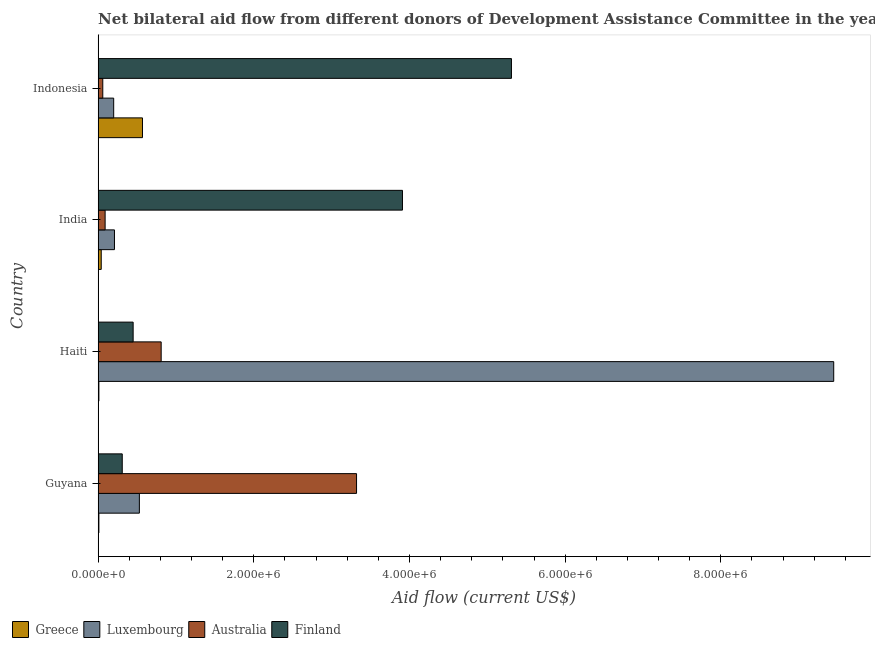How many groups of bars are there?
Make the answer very short. 4. How many bars are there on the 1st tick from the top?
Give a very brief answer. 4. How many bars are there on the 3rd tick from the bottom?
Offer a terse response. 4. What is the label of the 4th group of bars from the top?
Provide a short and direct response. Guyana. What is the amount of aid given by finland in Haiti?
Ensure brevity in your answer.  4.50e+05. Across all countries, what is the maximum amount of aid given by australia?
Make the answer very short. 3.32e+06. Across all countries, what is the minimum amount of aid given by luxembourg?
Make the answer very short. 2.00e+05. In which country was the amount of aid given by australia minimum?
Your answer should be compact. Indonesia. What is the total amount of aid given by finland in the graph?
Provide a succinct answer. 9.98e+06. What is the difference between the amount of aid given by luxembourg in Haiti and that in India?
Your answer should be compact. 9.24e+06. What is the difference between the amount of aid given by australia in Guyana and the amount of aid given by luxembourg in Haiti?
Keep it short and to the point. -6.13e+06. What is the average amount of aid given by australia per country?
Give a very brief answer. 1.07e+06. What is the difference between the amount of aid given by finland and amount of aid given by greece in Haiti?
Your response must be concise. 4.40e+05. In how many countries, is the amount of aid given by finland greater than 5200000 US$?
Ensure brevity in your answer.  1. What is the ratio of the amount of aid given by australia in India to that in Indonesia?
Give a very brief answer. 1.5. What is the difference between the highest and the second highest amount of aid given by finland?
Your response must be concise. 1.40e+06. What is the difference between the highest and the lowest amount of aid given by australia?
Provide a succinct answer. 3.26e+06. What does the 2nd bar from the bottom in India represents?
Make the answer very short. Luxembourg. How many countries are there in the graph?
Ensure brevity in your answer.  4. Does the graph contain any zero values?
Provide a short and direct response. No. Where does the legend appear in the graph?
Your answer should be very brief. Bottom left. What is the title of the graph?
Offer a terse response. Net bilateral aid flow from different donors of Development Assistance Committee in the year 2006. What is the Aid flow (current US$) in Luxembourg in Guyana?
Provide a succinct answer. 5.30e+05. What is the Aid flow (current US$) in Australia in Guyana?
Ensure brevity in your answer.  3.32e+06. What is the Aid flow (current US$) in Finland in Guyana?
Give a very brief answer. 3.10e+05. What is the Aid flow (current US$) of Luxembourg in Haiti?
Offer a terse response. 9.45e+06. What is the Aid flow (current US$) in Australia in Haiti?
Ensure brevity in your answer.  8.10e+05. What is the Aid flow (current US$) in Greece in India?
Make the answer very short. 4.00e+04. What is the Aid flow (current US$) of Luxembourg in India?
Provide a short and direct response. 2.10e+05. What is the Aid flow (current US$) in Australia in India?
Your response must be concise. 9.00e+04. What is the Aid flow (current US$) of Finland in India?
Provide a succinct answer. 3.91e+06. What is the Aid flow (current US$) in Greece in Indonesia?
Ensure brevity in your answer.  5.70e+05. What is the Aid flow (current US$) of Australia in Indonesia?
Your answer should be very brief. 6.00e+04. What is the Aid flow (current US$) of Finland in Indonesia?
Keep it short and to the point. 5.31e+06. Across all countries, what is the maximum Aid flow (current US$) of Greece?
Offer a terse response. 5.70e+05. Across all countries, what is the maximum Aid flow (current US$) in Luxembourg?
Provide a short and direct response. 9.45e+06. Across all countries, what is the maximum Aid flow (current US$) in Australia?
Provide a succinct answer. 3.32e+06. Across all countries, what is the maximum Aid flow (current US$) of Finland?
Provide a succinct answer. 5.31e+06. Across all countries, what is the minimum Aid flow (current US$) of Luxembourg?
Provide a succinct answer. 2.00e+05. Across all countries, what is the minimum Aid flow (current US$) in Finland?
Your answer should be compact. 3.10e+05. What is the total Aid flow (current US$) in Greece in the graph?
Your answer should be very brief. 6.30e+05. What is the total Aid flow (current US$) in Luxembourg in the graph?
Your answer should be compact. 1.04e+07. What is the total Aid flow (current US$) in Australia in the graph?
Offer a terse response. 4.28e+06. What is the total Aid flow (current US$) of Finland in the graph?
Offer a very short reply. 9.98e+06. What is the difference between the Aid flow (current US$) of Greece in Guyana and that in Haiti?
Give a very brief answer. 0. What is the difference between the Aid flow (current US$) in Luxembourg in Guyana and that in Haiti?
Offer a very short reply. -8.92e+06. What is the difference between the Aid flow (current US$) in Australia in Guyana and that in Haiti?
Your answer should be compact. 2.51e+06. What is the difference between the Aid flow (current US$) in Finland in Guyana and that in Haiti?
Your answer should be compact. -1.40e+05. What is the difference between the Aid flow (current US$) of Australia in Guyana and that in India?
Your response must be concise. 3.23e+06. What is the difference between the Aid flow (current US$) in Finland in Guyana and that in India?
Ensure brevity in your answer.  -3.60e+06. What is the difference between the Aid flow (current US$) in Greece in Guyana and that in Indonesia?
Offer a terse response. -5.60e+05. What is the difference between the Aid flow (current US$) of Australia in Guyana and that in Indonesia?
Offer a very short reply. 3.26e+06. What is the difference between the Aid flow (current US$) of Finland in Guyana and that in Indonesia?
Make the answer very short. -5.00e+06. What is the difference between the Aid flow (current US$) of Luxembourg in Haiti and that in India?
Your response must be concise. 9.24e+06. What is the difference between the Aid flow (current US$) of Australia in Haiti and that in India?
Provide a succinct answer. 7.20e+05. What is the difference between the Aid flow (current US$) of Finland in Haiti and that in India?
Your answer should be very brief. -3.46e+06. What is the difference between the Aid flow (current US$) of Greece in Haiti and that in Indonesia?
Offer a very short reply. -5.60e+05. What is the difference between the Aid flow (current US$) of Luxembourg in Haiti and that in Indonesia?
Make the answer very short. 9.25e+06. What is the difference between the Aid flow (current US$) in Australia in Haiti and that in Indonesia?
Offer a very short reply. 7.50e+05. What is the difference between the Aid flow (current US$) of Finland in Haiti and that in Indonesia?
Ensure brevity in your answer.  -4.86e+06. What is the difference between the Aid flow (current US$) in Greece in India and that in Indonesia?
Offer a terse response. -5.30e+05. What is the difference between the Aid flow (current US$) of Finland in India and that in Indonesia?
Make the answer very short. -1.40e+06. What is the difference between the Aid flow (current US$) of Greece in Guyana and the Aid flow (current US$) of Luxembourg in Haiti?
Your answer should be compact. -9.44e+06. What is the difference between the Aid flow (current US$) of Greece in Guyana and the Aid flow (current US$) of Australia in Haiti?
Keep it short and to the point. -8.00e+05. What is the difference between the Aid flow (current US$) of Greece in Guyana and the Aid flow (current US$) of Finland in Haiti?
Provide a short and direct response. -4.40e+05. What is the difference between the Aid flow (current US$) in Luxembourg in Guyana and the Aid flow (current US$) in Australia in Haiti?
Provide a succinct answer. -2.80e+05. What is the difference between the Aid flow (current US$) in Australia in Guyana and the Aid flow (current US$) in Finland in Haiti?
Your answer should be compact. 2.87e+06. What is the difference between the Aid flow (current US$) in Greece in Guyana and the Aid flow (current US$) in Luxembourg in India?
Provide a succinct answer. -2.00e+05. What is the difference between the Aid flow (current US$) in Greece in Guyana and the Aid flow (current US$) in Finland in India?
Provide a short and direct response. -3.90e+06. What is the difference between the Aid flow (current US$) of Luxembourg in Guyana and the Aid flow (current US$) of Australia in India?
Offer a terse response. 4.40e+05. What is the difference between the Aid flow (current US$) in Luxembourg in Guyana and the Aid flow (current US$) in Finland in India?
Your response must be concise. -3.38e+06. What is the difference between the Aid flow (current US$) in Australia in Guyana and the Aid flow (current US$) in Finland in India?
Provide a short and direct response. -5.90e+05. What is the difference between the Aid flow (current US$) in Greece in Guyana and the Aid flow (current US$) in Australia in Indonesia?
Your answer should be compact. -5.00e+04. What is the difference between the Aid flow (current US$) of Greece in Guyana and the Aid flow (current US$) of Finland in Indonesia?
Offer a very short reply. -5.30e+06. What is the difference between the Aid flow (current US$) of Luxembourg in Guyana and the Aid flow (current US$) of Australia in Indonesia?
Your answer should be compact. 4.70e+05. What is the difference between the Aid flow (current US$) of Luxembourg in Guyana and the Aid flow (current US$) of Finland in Indonesia?
Keep it short and to the point. -4.78e+06. What is the difference between the Aid flow (current US$) in Australia in Guyana and the Aid flow (current US$) in Finland in Indonesia?
Offer a terse response. -1.99e+06. What is the difference between the Aid flow (current US$) in Greece in Haiti and the Aid flow (current US$) in Finland in India?
Keep it short and to the point. -3.90e+06. What is the difference between the Aid flow (current US$) of Luxembourg in Haiti and the Aid flow (current US$) of Australia in India?
Your answer should be very brief. 9.36e+06. What is the difference between the Aid flow (current US$) in Luxembourg in Haiti and the Aid flow (current US$) in Finland in India?
Offer a very short reply. 5.54e+06. What is the difference between the Aid flow (current US$) of Australia in Haiti and the Aid flow (current US$) of Finland in India?
Offer a terse response. -3.10e+06. What is the difference between the Aid flow (current US$) in Greece in Haiti and the Aid flow (current US$) in Finland in Indonesia?
Offer a very short reply. -5.30e+06. What is the difference between the Aid flow (current US$) of Luxembourg in Haiti and the Aid flow (current US$) of Australia in Indonesia?
Offer a very short reply. 9.39e+06. What is the difference between the Aid flow (current US$) in Luxembourg in Haiti and the Aid flow (current US$) in Finland in Indonesia?
Make the answer very short. 4.14e+06. What is the difference between the Aid flow (current US$) of Australia in Haiti and the Aid flow (current US$) of Finland in Indonesia?
Offer a terse response. -4.50e+06. What is the difference between the Aid flow (current US$) of Greece in India and the Aid flow (current US$) of Luxembourg in Indonesia?
Offer a terse response. -1.60e+05. What is the difference between the Aid flow (current US$) in Greece in India and the Aid flow (current US$) in Australia in Indonesia?
Provide a short and direct response. -2.00e+04. What is the difference between the Aid flow (current US$) in Greece in India and the Aid flow (current US$) in Finland in Indonesia?
Give a very brief answer. -5.27e+06. What is the difference between the Aid flow (current US$) in Luxembourg in India and the Aid flow (current US$) in Australia in Indonesia?
Keep it short and to the point. 1.50e+05. What is the difference between the Aid flow (current US$) in Luxembourg in India and the Aid flow (current US$) in Finland in Indonesia?
Your answer should be compact. -5.10e+06. What is the difference between the Aid flow (current US$) of Australia in India and the Aid flow (current US$) of Finland in Indonesia?
Your answer should be compact. -5.22e+06. What is the average Aid flow (current US$) of Greece per country?
Your response must be concise. 1.58e+05. What is the average Aid flow (current US$) of Luxembourg per country?
Your response must be concise. 2.60e+06. What is the average Aid flow (current US$) of Australia per country?
Your answer should be compact. 1.07e+06. What is the average Aid flow (current US$) of Finland per country?
Provide a succinct answer. 2.50e+06. What is the difference between the Aid flow (current US$) of Greece and Aid flow (current US$) of Luxembourg in Guyana?
Offer a very short reply. -5.20e+05. What is the difference between the Aid flow (current US$) in Greece and Aid flow (current US$) in Australia in Guyana?
Your answer should be very brief. -3.31e+06. What is the difference between the Aid flow (current US$) of Greece and Aid flow (current US$) of Finland in Guyana?
Give a very brief answer. -3.00e+05. What is the difference between the Aid flow (current US$) of Luxembourg and Aid flow (current US$) of Australia in Guyana?
Offer a terse response. -2.79e+06. What is the difference between the Aid flow (current US$) in Australia and Aid flow (current US$) in Finland in Guyana?
Provide a succinct answer. 3.01e+06. What is the difference between the Aid flow (current US$) in Greece and Aid flow (current US$) in Luxembourg in Haiti?
Give a very brief answer. -9.44e+06. What is the difference between the Aid flow (current US$) of Greece and Aid flow (current US$) of Australia in Haiti?
Ensure brevity in your answer.  -8.00e+05. What is the difference between the Aid flow (current US$) of Greece and Aid flow (current US$) of Finland in Haiti?
Your response must be concise. -4.40e+05. What is the difference between the Aid flow (current US$) of Luxembourg and Aid flow (current US$) of Australia in Haiti?
Your response must be concise. 8.64e+06. What is the difference between the Aid flow (current US$) in Luxembourg and Aid flow (current US$) in Finland in Haiti?
Give a very brief answer. 9.00e+06. What is the difference between the Aid flow (current US$) in Australia and Aid flow (current US$) in Finland in Haiti?
Your answer should be compact. 3.60e+05. What is the difference between the Aid flow (current US$) of Greece and Aid flow (current US$) of Luxembourg in India?
Give a very brief answer. -1.70e+05. What is the difference between the Aid flow (current US$) in Greece and Aid flow (current US$) in Finland in India?
Offer a terse response. -3.87e+06. What is the difference between the Aid flow (current US$) in Luxembourg and Aid flow (current US$) in Australia in India?
Offer a very short reply. 1.20e+05. What is the difference between the Aid flow (current US$) of Luxembourg and Aid flow (current US$) of Finland in India?
Your answer should be very brief. -3.70e+06. What is the difference between the Aid flow (current US$) in Australia and Aid flow (current US$) in Finland in India?
Your answer should be very brief. -3.82e+06. What is the difference between the Aid flow (current US$) in Greece and Aid flow (current US$) in Luxembourg in Indonesia?
Your answer should be compact. 3.70e+05. What is the difference between the Aid flow (current US$) of Greece and Aid flow (current US$) of Australia in Indonesia?
Your response must be concise. 5.10e+05. What is the difference between the Aid flow (current US$) in Greece and Aid flow (current US$) in Finland in Indonesia?
Offer a terse response. -4.74e+06. What is the difference between the Aid flow (current US$) of Luxembourg and Aid flow (current US$) of Finland in Indonesia?
Provide a short and direct response. -5.11e+06. What is the difference between the Aid flow (current US$) in Australia and Aid flow (current US$) in Finland in Indonesia?
Offer a very short reply. -5.25e+06. What is the ratio of the Aid flow (current US$) in Luxembourg in Guyana to that in Haiti?
Provide a succinct answer. 0.06. What is the ratio of the Aid flow (current US$) of Australia in Guyana to that in Haiti?
Keep it short and to the point. 4.1. What is the ratio of the Aid flow (current US$) in Finland in Guyana to that in Haiti?
Give a very brief answer. 0.69. What is the ratio of the Aid flow (current US$) of Luxembourg in Guyana to that in India?
Provide a succinct answer. 2.52. What is the ratio of the Aid flow (current US$) in Australia in Guyana to that in India?
Provide a short and direct response. 36.89. What is the ratio of the Aid flow (current US$) in Finland in Guyana to that in India?
Provide a succinct answer. 0.08. What is the ratio of the Aid flow (current US$) in Greece in Guyana to that in Indonesia?
Provide a short and direct response. 0.02. What is the ratio of the Aid flow (current US$) of Luxembourg in Guyana to that in Indonesia?
Provide a succinct answer. 2.65. What is the ratio of the Aid flow (current US$) of Australia in Guyana to that in Indonesia?
Your answer should be very brief. 55.33. What is the ratio of the Aid flow (current US$) of Finland in Guyana to that in Indonesia?
Your answer should be compact. 0.06. What is the ratio of the Aid flow (current US$) in Finland in Haiti to that in India?
Offer a very short reply. 0.12. What is the ratio of the Aid flow (current US$) in Greece in Haiti to that in Indonesia?
Provide a succinct answer. 0.02. What is the ratio of the Aid flow (current US$) in Luxembourg in Haiti to that in Indonesia?
Offer a terse response. 47.25. What is the ratio of the Aid flow (current US$) in Finland in Haiti to that in Indonesia?
Provide a short and direct response. 0.08. What is the ratio of the Aid flow (current US$) in Greece in India to that in Indonesia?
Your answer should be compact. 0.07. What is the ratio of the Aid flow (current US$) in Luxembourg in India to that in Indonesia?
Provide a short and direct response. 1.05. What is the ratio of the Aid flow (current US$) in Australia in India to that in Indonesia?
Offer a very short reply. 1.5. What is the ratio of the Aid flow (current US$) in Finland in India to that in Indonesia?
Give a very brief answer. 0.74. What is the difference between the highest and the second highest Aid flow (current US$) in Greece?
Make the answer very short. 5.30e+05. What is the difference between the highest and the second highest Aid flow (current US$) of Luxembourg?
Ensure brevity in your answer.  8.92e+06. What is the difference between the highest and the second highest Aid flow (current US$) in Australia?
Your answer should be compact. 2.51e+06. What is the difference between the highest and the second highest Aid flow (current US$) of Finland?
Give a very brief answer. 1.40e+06. What is the difference between the highest and the lowest Aid flow (current US$) in Greece?
Give a very brief answer. 5.60e+05. What is the difference between the highest and the lowest Aid flow (current US$) in Luxembourg?
Provide a short and direct response. 9.25e+06. What is the difference between the highest and the lowest Aid flow (current US$) in Australia?
Your answer should be compact. 3.26e+06. 